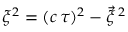<formula> <loc_0><loc_0><loc_500><loc_500>\xi ^ { 2 } = ( c \, \tau ) ^ { 2 } - \vec { \xi } \, ^ { 2 }</formula> 